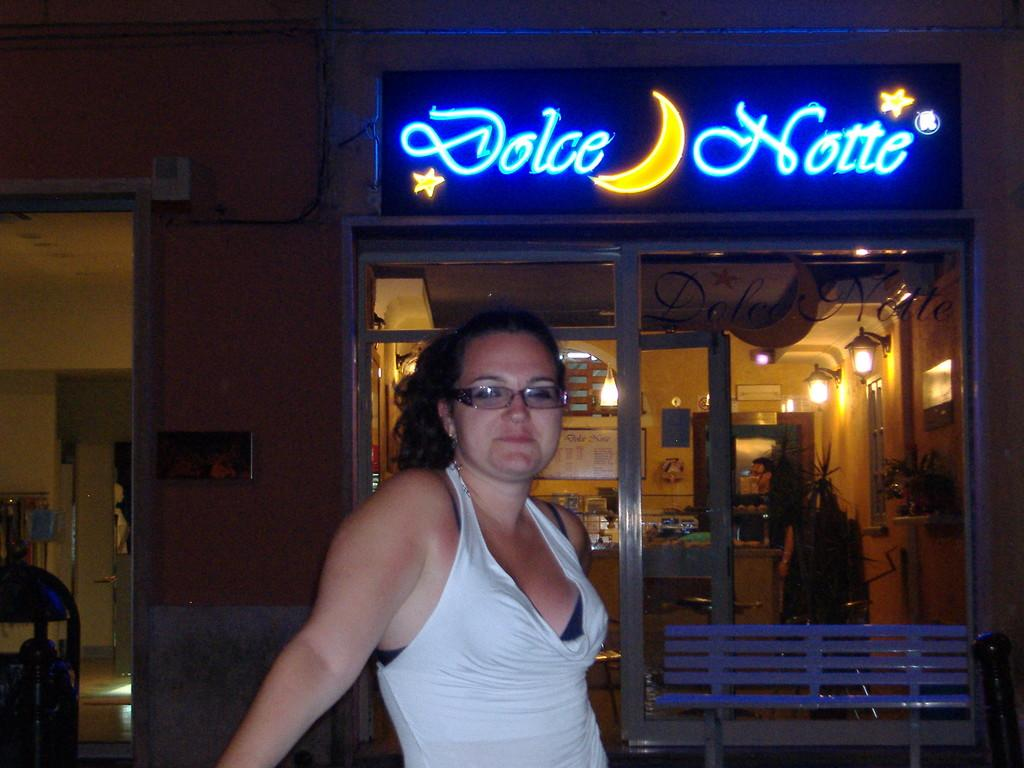Who is the main subject in the image? There is a woman in the center of the image. What is the woman wearing? The woman is wearing white clothes. Are there any accessories visible on the woman? Yes, the woman is wearing spectacles. What can be seen behind the woman in the image? There is a stall visible behind the woman. What is written or displayed on the stall? There is some text on the stall. How does the woman maintain her health in the image? There is no information about the woman's health in the image, so we cannot determine how she maintains it. What is the woman doing to get the attention of the people around her in the image? There is no indication in the image that the woman is trying to get anyone's attention. What type of rake is visible in the image? There is no rake present in the image. 